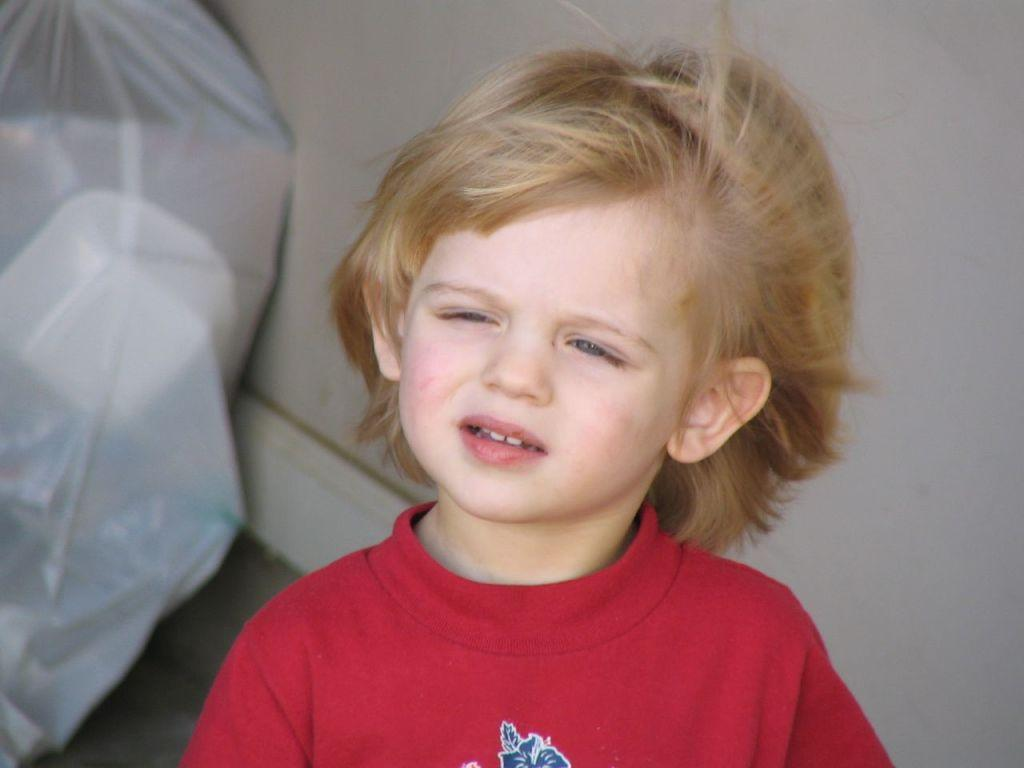Who is the main subject in the image? There is a boy in the image. What is the boy wearing? The boy is wearing a red shirt. What can be seen in the background of the image? There is a packet and a wall in the background of the image. What type of soda is the boy drinking in the image? There is no soda present in the image; the boy is not drinking anything. What color is the ink used for the writing on the packet in the image? There is no writing or ink visible on the packet in the image. 